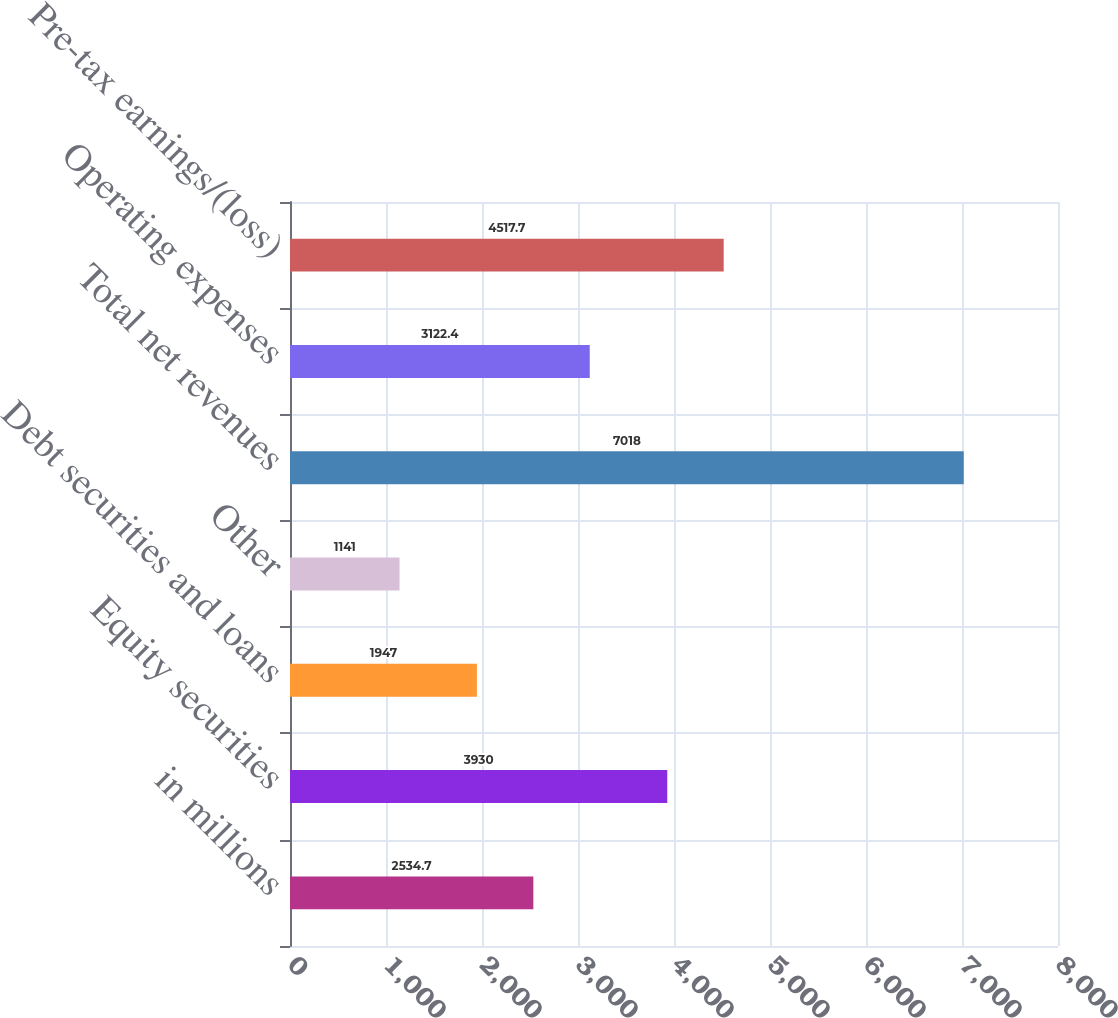Convert chart to OTSL. <chart><loc_0><loc_0><loc_500><loc_500><bar_chart><fcel>in millions<fcel>Equity securities<fcel>Debt securities and loans<fcel>Other<fcel>Total net revenues<fcel>Operating expenses<fcel>Pre-tax earnings/(loss)<nl><fcel>2534.7<fcel>3930<fcel>1947<fcel>1141<fcel>7018<fcel>3122.4<fcel>4517.7<nl></chart> 